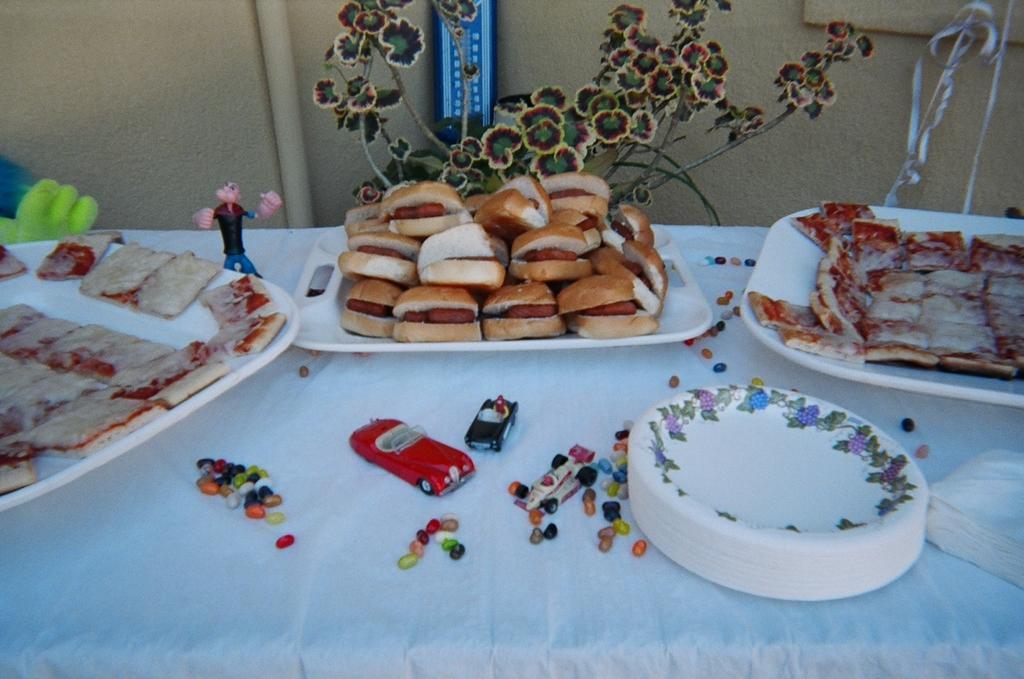Could you give a brief overview of what you see in this image? In the image on the table there are trays with food items. And also there are plates, tissues and toys. Behind the table there is a wall with pipe and a blue color object. 